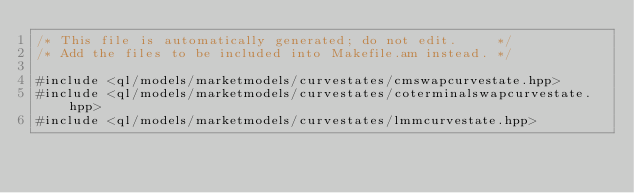Convert code to text. <code><loc_0><loc_0><loc_500><loc_500><_C++_>/* This file is automatically generated; do not edit.     */
/* Add the files to be included into Makefile.am instead. */

#include <ql/models/marketmodels/curvestates/cmswapcurvestate.hpp>
#include <ql/models/marketmodels/curvestates/coterminalswapcurvestate.hpp>
#include <ql/models/marketmodels/curvestates/lmmcurvestate.hpp>

</code> 